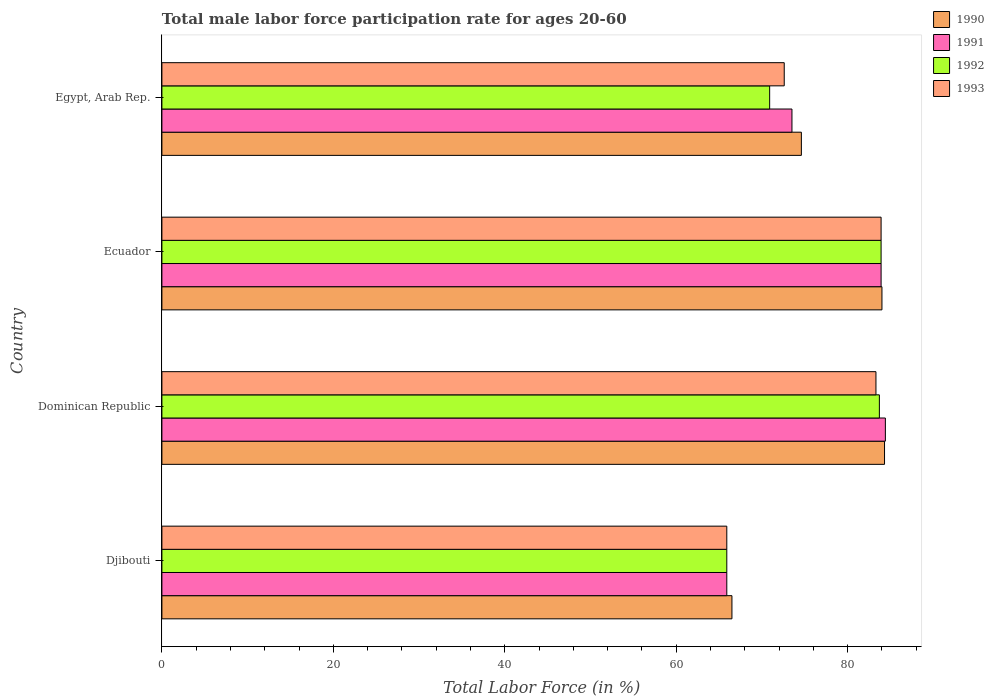How many groups of bars are there?
Keep it short and to the point. 4. Are the number of bars per tick equal to the number of legend labels?
Provide a succinct answer. Yes. How many bars are there on the 2nd tick from the bottom?
Offer a terse response. 4. What is the label of the 1st group of bars from the top?
Your response must be concise. Egypt, Arab Rep. In how many cases, is the number of bars for a given country not equal to the number of legend labels?
Offer a very short reply. 0. What is the male labor force participation rate in 1991 in Dominican Republic?
Provide a succinct answer. 84.4. Across all countries, what is the maximum male labor force participation rate in 1993?
Make the answer very short. 83.9. Across all countries, what is the minimum male labor force participation rate in 1992?
Provide a short and direct response. 65.9. In which country was the male labor force participation rate in 1990 maximum?
Ensure brevity in your answer.  Dominican Republic. In which country was the male labor force participation rate in 1993 minimum?
Your answer should be very brief. Djibouti. What is the total male labor force participation rate in 1991 in the graph?
Give a very brief answer. 307.7. What is the difference between the male labor force participation rate in 1990 in Djibouti and that in Ecuador?
Give a very brief answer. -17.5. What is the difference between the male labor force participation rate in 1991 in Egypt, Arab Rep. and the male labor force participation rate in 1990 in Djibouti?
Your answer should be very brief. 7. What is the average male labor force participation rate in 1992 per country?
Make the answer very short. 76.1. What is the difference between the male labor force participation rate in 1990 and male labor force participation rate in 1992 in Ecuador?
Give a very brief answer. 0.1. What is the ratio of the male labor force participation rate in 1993 in Dominican Republic to that in Ecuador?
Give a very brief answer. 0.99. What is the difference between the highest and the second highest male labor force participation rate in 1993?
Keep it short and to the point. 0.6. What is the difference between the highest and the lowest male labor force participation rate in 1992?
Your response must be concise. 18. In how many countries, is the male labor force participation rate in 1992 greater than the average male labor force participation rate in 1992 taken over all countries?
Offer a terse response. 2. Is the sum of the male labor force participation rate in 1991 in Dominican Republic and Ecuador greater than the maximum male labor force participation rate in 1990 across all countries?
Ensure brevity in your answer.  Yes. What does the 2nd bar from the top in Djibouti represents?
Provide a short and direct response. 1992. What does the 1st bar from the bottom in Dominican Republic represents?
Your response must be concise. 1990. Are all the bars in the graph horizontal?
Make the answer very short. Yes. How many countries are there in the graph?
Provide a short and direct response. 4. Does the graph contain grids?
Offer a terse response. No. How many legend labels are there?
Your answer should be very brief. 4. How are the legend labels stacked?
Offer a very short reply. Vertical. What is the title of the graph?
Offer a very short reply. Total male labor force participation rate for ages 20-60. Does "1997" appear as one of the legend labels in the graph?
Ensure brevity in your answer.  No. What is the label or title of the Y-axis?
Offer a terse response. Country. What is the Total Labor Force (in %) of 1990 in Djibouti?
Make the answer very short. 66.5. What is the Total Labor Force (in %) in 1991 in Djibouti?
Offer a terse response. 65.9. What is the Total Labor Force (in %) of 1992 in Djibouti?
Offer a terse response. 65.9. What is the Total Labor Force (in %) in 1993 in Djibouti?
Offer a very short reply. 65.9. What is the Total Labor Force (in %) of 1990 in Dominican Republic?
Offer a terse response. 84.3. What is the Total Labor Force (in %) in 1991 in Dominican Republic?
Offer a terse response. 84.4. What is the Total Labor Force (in %) in 1992 in Dominican Republic?
Your answer should be compact. 83.7. What is the Total Labor Force (in %) in 1993 in Dominican Republic?
Ensure brevity in your answer.  83.3. What is the Total Labor Force (in %) of 1990 in Ecuador?
Your answer should be compact. 84. What is the Total Labor Force (in %) of 1991 in Ecuador?
Give a very brief answer. 83.9. What is the Total Labor Force (in %) of 1992 in Ecuador?
Keep it short and to the point. 83.9. What is the Total Labor Force (in %) in 1993 in Ecuador?
Provide a short and direct response. 83.9. What is the Total Labor Force (in %) of 1990 in Egypt, Arab Rep.?
Ensure brevity in your answer.  74.6. What is the Total Labor Force (in %) in 1991 in Egypt, Arab Rep.?
Offer a very short reply. 73.5. What is the Total Labor Force (in %) in 1992 in Egypt, Arab Rep.?
Ensure brevity in your answer.  70.9. What is the Total Labor Force (in %) of 1993 in Egypt, Arab Rep.?
Provide a succinct answer. 72.6. Across all countries, what is the maximum Total Labor Force (in %) of 1990?
Make the answer very short. 84.3. Across all countries, what is the maximum Total Labor Force (in %) in 1991?
Offer a very short reply. 84.4. Across all countries, what is the maximum Total Labor Force (in %) in 1992?
Provide a succinct answer. 83.9. Across all countries, what is the maximum Total Labor Force (in %) of 1993?
Your response must be concise. 83.9. Across all countries, what is the minimum Total Labor Force (in %) in 1990?
Provide a succinct answer. 66.5. Across all countries, what is the minimum Total Labor Force (in %) of 1991?
Your response must be concise. 65.9. Across all countries, what is the minimum Total Labor Force (in %) in 1992?
Your response must be concise. 65.9. Across all countries, what is the minimum Total Labor Force (in %) in 1993?
Ensure brevity in your answer.  65.9. What is the total Total Labor Force (in %) of 1990 in the graph?
Offer a terse response. 309.4. What is the total Total Labor Force (in %) in 1991 in the graph?
Offer a very short reply. 307.7. What is the total Total Labor Force (in %) in 1992 in the graph?
Ensure brevity in your answer.  304.4. What is the total Total Labor Force (in %) in 1993 in the graph?
Offer a terse response. 305.7. What is the difference between the Total Labor Force (in %) in 1990 in Djibouti and that in Dominican Republic?
Keep it short and to the point. -17.8. What is the difference between the Total Labor Force (in %) of 1991 in Djibouti and that in Dominican Republic?
Provide a succinct answer. -18.5. What is the difference between the Total Labor Force (in %) in 1992 in Djibouti and that in Dominican Republic?
Make the answer very short. -17.8. What is the difference between the Total Labor Force (in %) of 1993 in Djibouti and that in Dominican Republic?
Give a very brief answer. -17.4. What is the difference between the Total Labor Force (in %) of 1990 in Djibouti and that in Ecuador?
Ensure brevity in your answer.  -17.5. What is the difference between the Total Labor Force (in %) in 1991 in Djibouti and that in Ecuador?
Your answer should be compact. -18. What is the difference between the Total Labor Force (in %) in 1992 in Djibouti and that in Ecuador?
Give a very brief answer. -18. What is the difference between the Total Labor Force (in %) in 1993 in Djibouti and that in Ecuador?
Keep it short and to the point. -18. What is the difference between the Total Labor Force (in %) of 1990 in Djibouti and that in Egypt, Arab Rep.?
Your answer should be compact. -8.1. What is the difference between the Total Labor Force (in %) in 1991 in Djibouti and that in Egypt, Arab Rep.?
Make the answer very short. -7.6. What is the difference between the Total Labor Force (in %) of 1991 in Dominican Republic and that in Ecuador?
Give a very brief answer. 0.5. What is the difference between the Total Labor Force (in %) of 1992 in Dominican Republic and that in Ecuador?
Give a very brief answer. -0.2. What is the difference between the Total Labor Force (in %) of 1993 in Dominican Republic and that in Ecuador?
Your answer should be compact. -0.6. What is the difference between the Total Labor Force (in %) of 1990 in Dominican Republic and that in Egypt, Arab Rep.?
Make the answer very short. 9.7. What is the difference between the Total Labor Force (in %) of 1990 in Ecuador and that in Egypt, Arab Rep.?
Give a very brief answer. 9.4. What is the difference between the Total Labor Force (in %) of 1991 in Ecuador and that in Egypt, Arab Rep.?
Your answer should be very brief. 10.4. What is the difference between the Total Labor Force (in %) in 1992 in Ecuador and that in Egypt, Arab Rep.?
Provide a succinct answer. 13. What is the difference between the Total Labor Force (in %) in 1990 in Djibouti and the Total Labor Force (in %) in 1991 in Dominican Republic?
Give a very brief answer. -17.9. What is the difference between the Total Labor Force (in %) of 1990 in Djibouti and the Total Labor Force (in %) of 1992 in Dominican Republic?
Provide a succinct answer. -17.2. What is the difference between the Total Labor Force (in %) in 1990 in Djibouti and the Total Labor Force (in %) in 1993 in Dominican Republic?
Offer a very short reply. -16.8. What is the difference between the Total Labor Force (in %) in 1991 in Djibouti and the Total Labor Force (in %) in 1992 in Dominican Republic?
Give a very brief answer. -17.8. What is the difference between the Total Labor Force (in %) of 1991 in Djibouti and the Total Labor Force (in %) of 1993 in Dominican Republic?
Ensure brevity in your answer.  -17.4. What is the difference between the Total Labor Force (in %) of 1992 in Djibouti and the Total Labor Force (in %) of 1993 in Dominican Republic?
Your response must be concise. -17.4. What is the difference between the Total Labor Force (in %) in 1990 in Djibouti and the Total Labor Force (in %) in 1991 in Ecuador?
Offer a terse response. -17.4. What is the difference between the Total Labor Force (in %) in 1990 in Djibouti and the Total Labor Force (in %) in 1992 in Ecuador?
Give a very brief answer. -17.4. What is the difference between the Total Labor Force (in %) of 1990 in Djibouti and the Total Labor Force (in %) of 1993 in Ecuador?
Offer a very short reply. -17.4. What is the difference between the Total Labor Force (in %) in 1992 in Djibouti and the Total Labor Force (in %) in 1993 in Ecuador?
Your answer should be compact. -18. What is the difference between the Total Labor Force (in %) of 1990 in Djibouti and the Total Labor Force (in %) of 1991 in Egypt, Arab Rep.?
Your response must be concise. -7. What is the difference between the Total Labor Force (in %) of 1990 in Dominican Republic and the Total Labor Force (in %) of 1991 in Ecuador?
Make the answer very short. 0.4. What is the difference between the Total Labor Force (in %) in 1991 in Dominican Republic and the Total Labor Force (in %) in 1993 in Ecuador?
Your answer should be compact. 0.5. What is the difference between the Total Labor Force (in %) in 1992 in Dominican Republic and the Total Labor Force (in %) in 1993 in Ecuador?
Provide a short and direct response. -0.2. What is the difference between the Total Labor Force (in %) in 1990 in Dominican Republic and the Total Labor Force (in %) in 1991 in Egypt, Arab Rep.?
Give a very brief answer. 10.8. What is the difference between the Total Labor Force (in %) of 1990 in Ecuador and the Total Labor Force (in %) of 1991 in Egypt, Arab Rep.?
Ensure brevity in your answer.  10.5. What is the difference between the Total Labor Force (in %) in 1990 in Ecuador and the Total Labor Force (in %) in 1992 in Egypt, Arab Rep.?
Offer a terse response. 13.1. What is the difference between the Total Labor Force (in %) of 1990 in Ecuador and the Total Labor Force (in %) of 1993 in Egypt, Arab Rep.?
Make the answer very short. 11.4. What is the difference between the Total Labor Force (in %) of 1991 in Ecuador and the Total Labor Force (in %) of 1992 in Egypt, Arab Rep.?
Ensure brevity in your answer.  13. What is the average Total Labor Force (in %) in 1990 per country?
Ensure brevity in your answer.  77.35. What is the average Total Labor Force (in %) in 1991 per country?
Give a very brief answer. 76.92. What is the average Total Labor Force (in %) in 1992 per country?
Provide a short and direct response. 76.1. What is the average Total Labor Force (in %) in 1993 per country?
Ensure brevity in your answer.  76.42. What is the difference between the Total Labor Force (in %) of 1990 and Total Labor Force (in %) of 1991 in Djibouti?
Your answer should be compact. 0.6. What is the difference between the Total Labor Force (in %) in 1990 and Total Labor Force (in %) in 1992 in Djibouti?
Offer a very short reply. 0.6. What is the difference between the Total Labor Force (in %) in 1991 and Total Labor Force (in %) in 1992 in Djibouti?
Your answer should be very brief. 0. What is the difference between the Total Labor Force (in %) of 1990 and Total Labor Force (in %) of 1991 in Dominican Republic?
Offer a terse response. -0.1. What is the difference between the Total Labor Force (in %) in 1990 and Total Labor Force (in %) in 1992 in Dominican Republic?
Offer a very short reply. 0.6. What is the difference between the Total Labor Force (in %) of 1990 and Total Labor Force (in %) of 1993 in Dominican Republic?
Make the answer very short. 1. What is the difference between the Total Labor Force (in %) in 1991 and Total Labor Force (in %) in 1993 in Ecuador?
Keep it short and to the point. 0. What is the difference between the Total Labor Force (in %) in 1990 and Total Labor Force (in %) in 1991 in Egypt, Arab Rep.?
Offer a very short reply. 1.1. What is the difference between the Total Labor Force (in %) in 1990 and Total Labor Force (in %) in 1992 in Egypt, Arab Rep.?
Your answer should be compact. 3.7. What is the difference between the Total Labor Force (in %) of 1990 and Total Labor Force (in %) of 1993 in Egypt, Arab Rep.?
Keep it short and to the point. 2. What is the difference between the Total Labor Force (in %) of 1991 and Total Labor Force (in %) of 1993 in Egypt, Arab Rep.?
Give a very brief answer. 0.9. What is the ratio of the Total Labor Force (in %) of 1990 in Djibouti to that in Dominican Republic?
Provide a short and direct response. 0.79. What is the ratio of the Total Labor Force (in %) in 1991 in Djibouti to that in Dominican Republic?
Offer a very short reply. 0.78. What is the ratio of the Total Labor Force (in %) in 1992 in Djibouti to that in Dominican Republic?
Offer a terse response. 0.79. What is the ratio of the Total Labor Force (in %) of 1993 in Djibouti to that in Dominican Republic?
Offer a terse response. 0.79. What is the ratio of the Total Labor Force (in %) in 1990 in Djibouti to that in Ecuador?
Offer a terse response. 0.79. What is the ratio of the Total Labor Force (in %) of 1991 in Djibouti to that in Ecuador?
Your answer should be very brief. 0.79. What is the ratio of the Total Labor Force (in %) in 1992 in Djibouti to that in Ecuador?
Provide a short and direct response. 0.79. What is the ratio of the Total Labor Force (in %) in 1993 in Djibouti to that in Ecuador?
Your answer should be compact. 0.79. What is the ratio of the Total Labor Force (in %) in 1990 in Djibouti to that in Egypt, Arab Rep.?
Ensure brevity in your answer.  0.89. What is the ratio of the Total Labor Force (in %) in 1991 in Djibouti to that in Egypt, Arab Rep.?
Offer a terse response. 0.9. What is the ratio of the Total Labor Force (in %) of 1992 in Djibouti to that in Egypt, Arab Rep.?
Make the answer very short. 0.93. What is the ratio of the Total Labor Force (in %) in 1993 in Djibouti to that in Egypt, Arab Rep.?
Provide a short and direct response. 0.91. What is the ratio of the Total Labor Force (in %) of 1991 in Dominican Republic to that in Ecuador?
Provide a succinct answer. 1.01. What is the ratio of the Total Labor Force (in %) of 1990 in Dominican Republic to that in Egypt, Arab Rep.?
Your answer should be very brief. 1.13. What is the ratio of the Total Labor Force (in %) in 1991 in Dominican Republic to that in Egypt, Arab Rep.?
Make the answer very short. 1.15. What is the ratio of the Total Labor Force (in %) of 1992 in Dominican Republic to that in Egypt, Arab Rep.?
Offer a very short reply. 1.18. What is the ratio of the Total Labor Force (in %) in 1993 in Dominican Republic to that in Egypt, Arab Rep.?
Your answer should be very brief. 1.15. What is the ratio of the Total Labor Force (in %) in 1990 in Ecuador to that in Egypt, Arab Rep.?
Make the answer very short. 1.13. What is the ratio of the Total Labor Force (in %) of 1991 in Ecuador to that in Egypt, Arab Rep.?
Your answer should be compact. 1.14. What is the ratio of the Total Labor Force (in %) of 1992 in Ecuador to that in Egypt, Arab Rep.?
Provide a succinct answer. 1.18. What is the ratio of the Total Labor Force (in %) of 1993 in Ecuador to that in Egypt, Arab Rep.?
Give a very brief answer. 1.16. What is the difference between the highest and the second highest Total Labor Force (in %) of 1991?
Your response must be concise. 0.5. What is the difference between the highest and the second highest Total Labor Force (in %) of 1992?
Your answer should be compact. 0.2. What is the difference between the highest and the second highest Total Labor Force (in %) of 1993?
Your answer should be very brief. 0.6. What is the difference between the highest and the lowest Total Labor Force (in %) in 1993?
Keep it short and to the point. 18. 